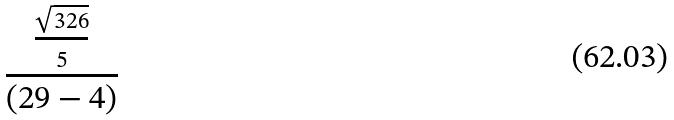Convert formula to latex. <formula><loc_0><loc_0><loc_500><loc_500>\frac { \frac { \sqrt { 3 2 6 } } { 5 } } { ( 2 9 - 4 ) }</formula> 